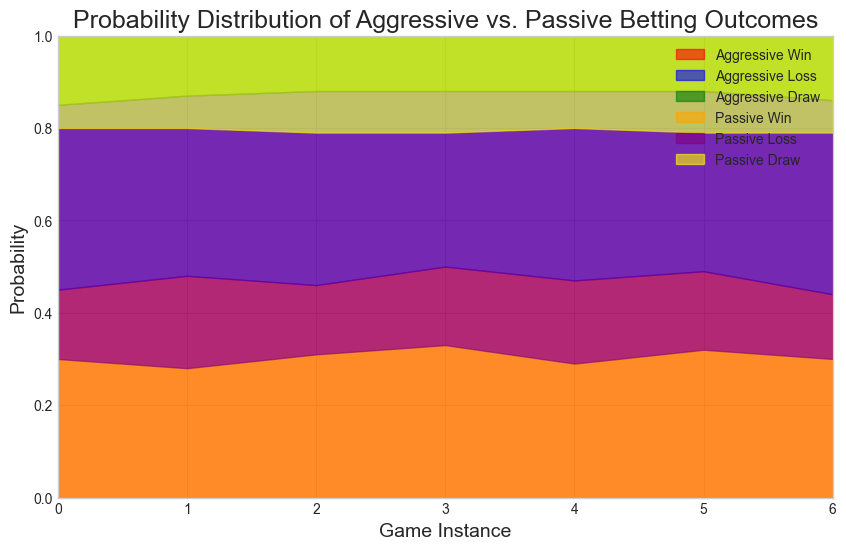What's the win probability trend for aggressive betting? By visually examining the red area in the figure representing aggressive wins, we can see if the area is generally increasing, decreasing, or remaining constant.
Answer: Generally increasing Which betting style has a higher loss probability? Comparing the blue and purple areas in the figure, blue represents aggressive losses and purple represents passive losses. We check which area is consistently higher in height.
Answer: Passive During which game instance does the win probability for aggressive betting peak? By observing the red area to find the highest point it reaches on the y-axis, we can determine the game instance.
Answer: Instance 3 Is there any instance where aggressive betting has a lower loss probability than passive betting? We compare the heights of the blue (aggressive loss) and purple (passive loss) areas at each game instance to see if any aggressive loss height is less than the corresponding passive loss height.
Answer: No What is the total probability of winning and drawing for passive betting in instance 1? We sum the heights of the orange (passive win) and yellow (passive draw) areas at instance 1.
Answer: 0.50 Which betting style has a more consistent win probability? By examining the fluctuations in the heights of the red (aggressive win) and orange (passive win) areas across all instances, we can determine which is more stable.
Answer: Aggressive How does the loss probability for passive betting change over time? Looking at the purple area representing passive losses, we can describe if it is increasing, decreasing, or fluctuating.
Answer: Fluctuating For which betting style is the draw probability generally higher? By comparing the green (aggressive draw) and yellow (passive draw) areas, we see which one generally reaches higher.
Answer: Passive What's the highest combined probability of winning and losing for aggressive betting across all instances? For these, we sum the heights of the red (win) and blue (lose) areas for each instance for aggressive and identify the maximum value.
Answer: 0.89 